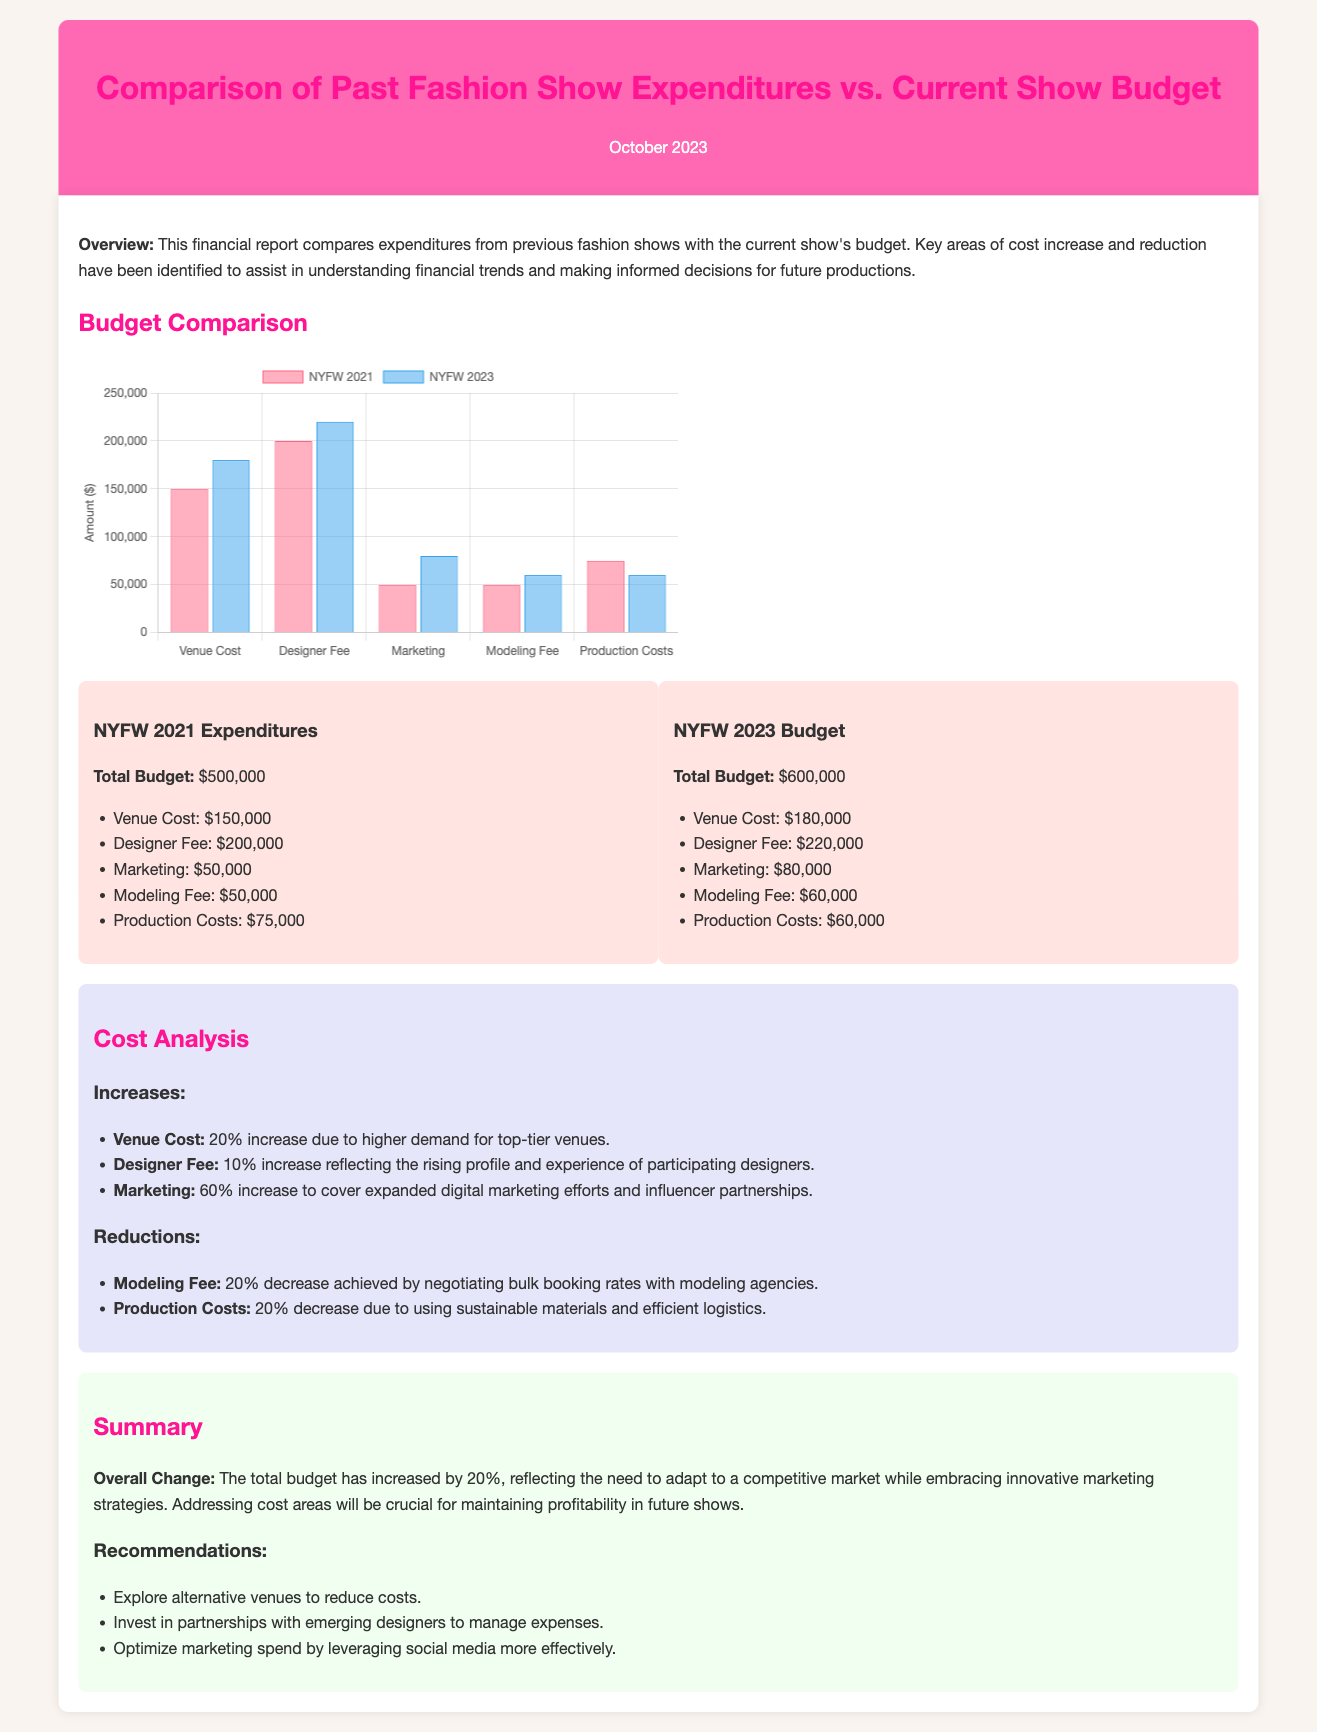What was the total budget for NYFW 2021? The document lists the total budget for NYFW 2021 as $500,000.
Answer: $500,000 What was the marketing cost for NYFW 2023? The budget for marketing in NYFW 2023 is explicitly stated as $80,000.
Answer: $80,000 What percentage increase was observed in venue costs? The document indicates a 20% increase in venue costs, thus reflecting the current market demand.
Answer: 20% How much did the designer fees increase? The document notes that designer fees increased by 10%, indicating an upward trend in artist payment.
Answer: 10% What is the total budget for NYFW 2023? The total budget for NYFW 2023 is detailed in the document as $600,000.
Answer: $600,000 Which cost category saw the largest increase? The cost category with the largest increase is marketing, which rose by 60%.
Answer: Marketing What percentage decrease was achieved in modeling fees? The modeling fees decreased by 20%, showing effective negotiation strategies employed.
Answer: 20% What is the overall change in total budget from 2021 to 2023? The overall change reflects a 20% increase in the total budget, highlighting adjustments in spending.
Answer: 20% What recommendation is given regarding venue costs? The recommendation suggests exploring alternative venues to help mitigate expenses.
Answer: Explore alternative venues 